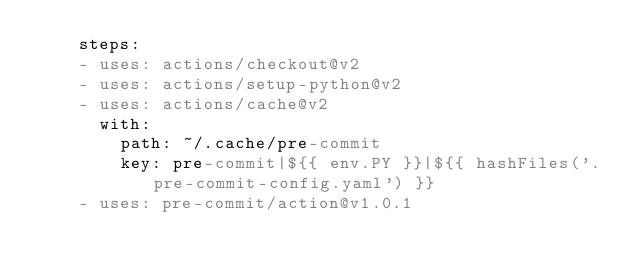<code> <loc_0><loc_0><loc_500><loc_500><_YAML_>    steps:
    - uses: actions/checkout@v2
    - uses: actions/setup-python@v2
    - uses: actions/cache@v2
      with:
        path: ~/.cache/pre-commit
        key: pre-commit|${{ env.PY }}|${{ hashFiles('.pre-commit-config.yaml') }}
    - uses: pre-commit/action@v1.0.1
</code> 